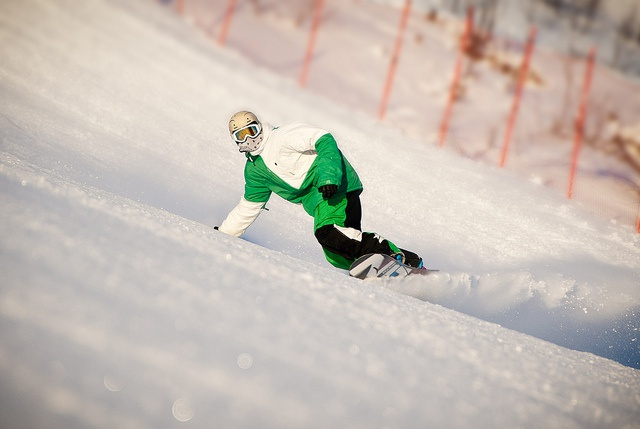Describe the objects in this image and their specific colors. I can see people in tan, ivory, black, green, and darkgreen tones and snowboard in tan, gray, darkgray, and lightgray tones in this image. 